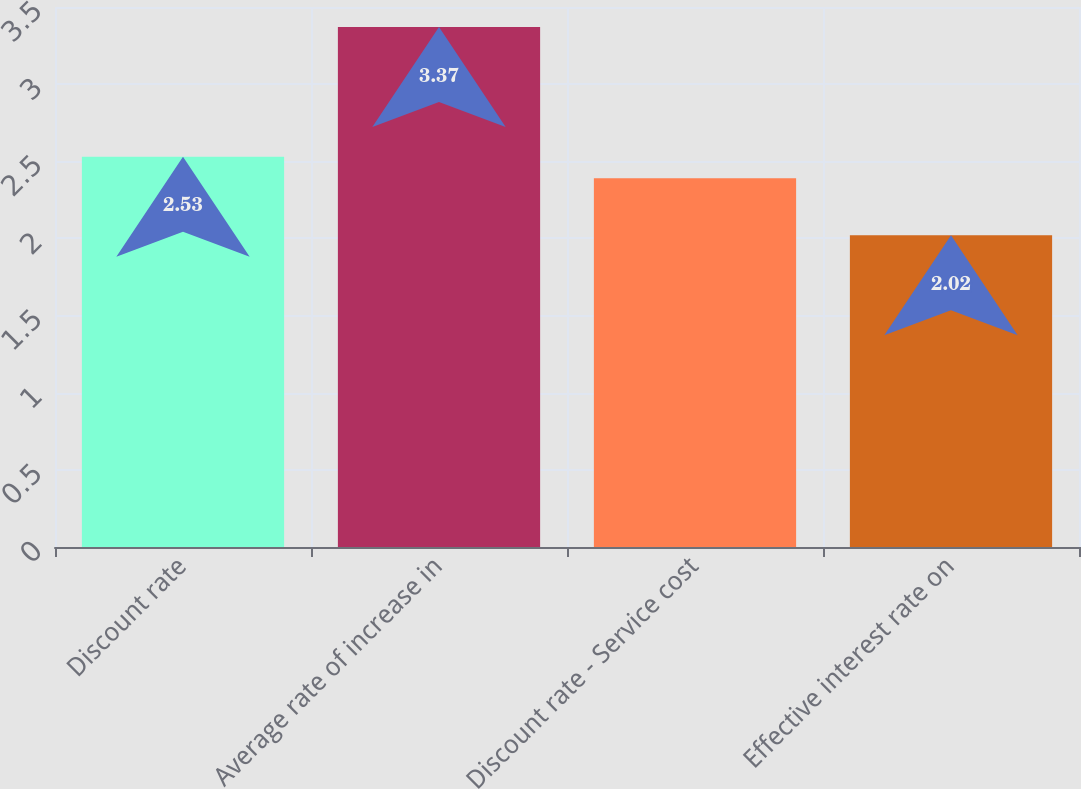Convert chart. <chart><loc_0><loc_0><loc_500><loc_500><bar_chart><fcel>Discount rate<fcel>Average rate of increase in<fcel>Discount rate - Service cost<fcel>Effective interest rate on<nl><fcel>2.53<fcel>3.37<fcel>2.39<fcel>2.02<nl></chart> 